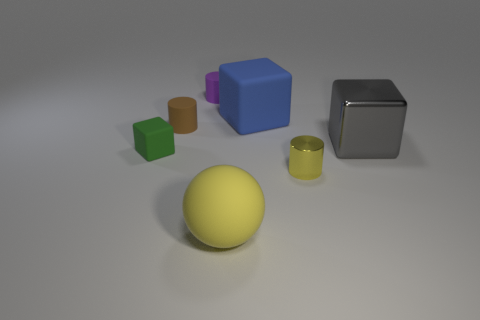Add 2 small red metal objects. How many objects exist? 9 Subtract all blue blocks. Subtract all yellow cylinders. How many blocks are left? 2 Subtract all cubes. How many objects are left? 4 Add 7 small purple cylinders. How many small purple cylinders are left? 8 Add 7 big yellow shiny things. How many big yellow shiny things exist? 7 Subtract 0 red spheres. How many objects are left? 7 Subtract all brown rubber things. Subtract all red metal blocks. How many objects are left? 6 